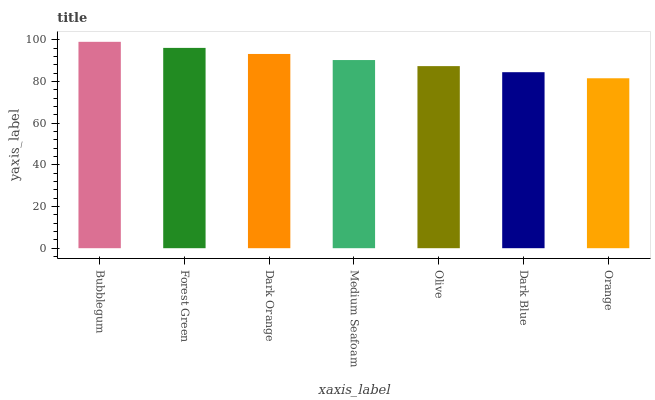Is Orange the minimum?
Answer yes or no. Yes. Is Bubblegum the maximum?
Answer yes or no. Yes. Is Forest Green the minimum?
Answer yes or no. No. Is Forest Green the maximum?
Answer yes or no. No. Is Bubblegum greater than Forest Green?
Answer yes or no. Yes. Is Forest Green less than Bubblegum?
Answer yes or no. Yes. Is Forest Green greater than Bubblegum?
Answer yes or no. No. Is Bubblegum less than Forest Green?
Answer yes or no. No. Is Medium Seafoam the high median?
Answer yes or no. Yes. Is Medium Seafoam the low median?
Answer yes or no. Yes. Is Olive the high median?
Answer yes or no. No. Is Olive the low median?
Answer yes or no. No. 